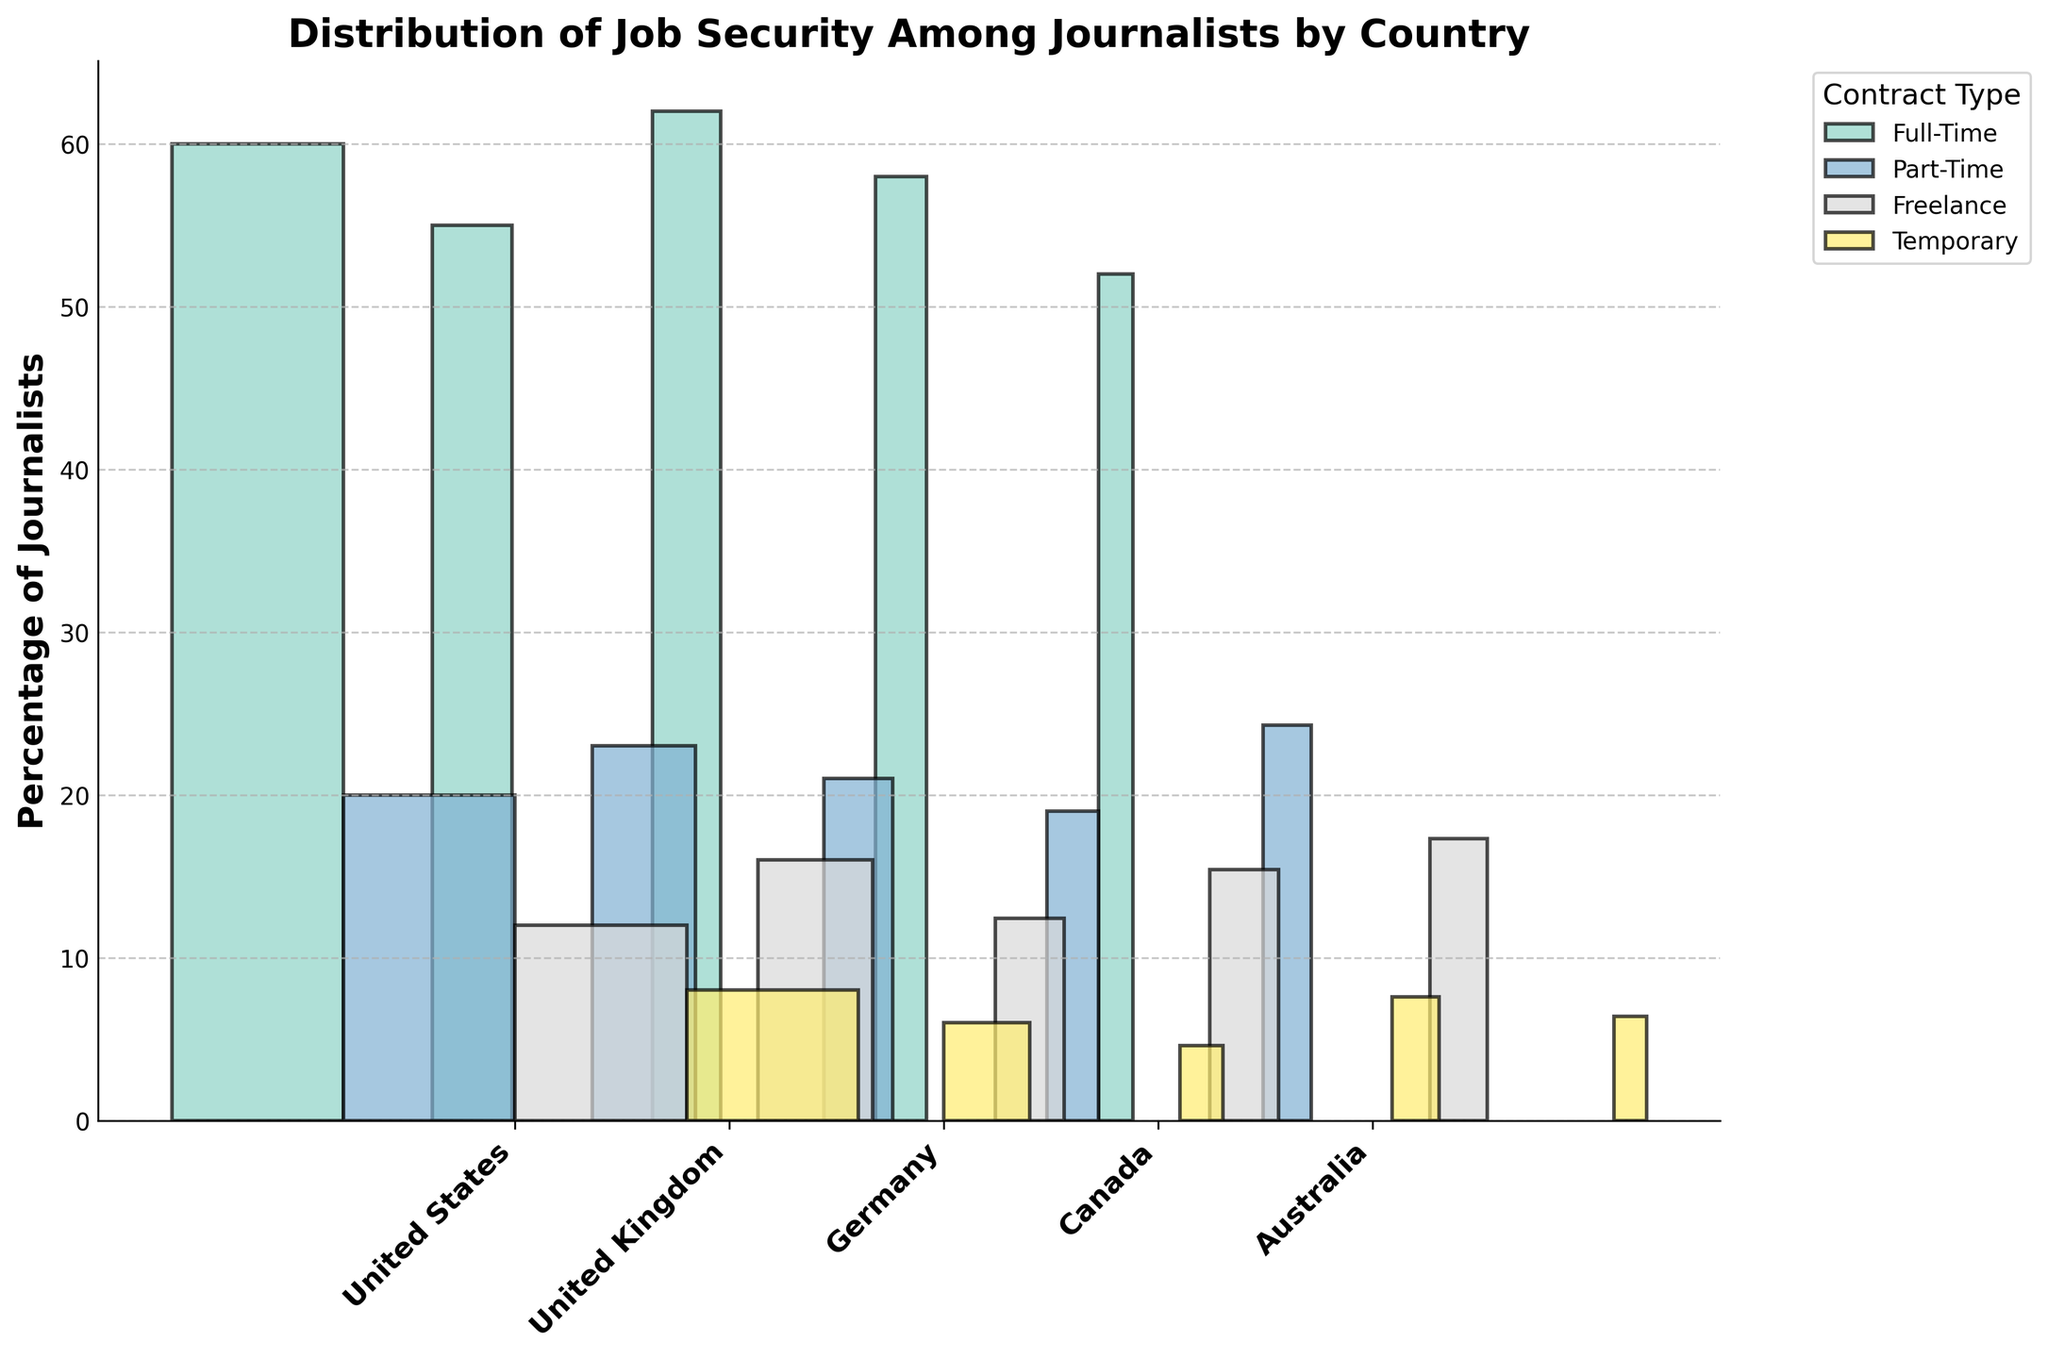What is the title of the plot? The title is usually found at the top of the plot. It indicates the main focus of the data presented. In this case, it reads "Distribution of Job Security Among Journalists by Country."
Answer: Distribution of Job Security Among Journalists by Country Which country has the highest percentage of journalists working full-time? To find this, look at the bars corresponding to the "Full-Time" label across all countries and identify the one with the highest value.
Answer: Germany Which contract type shows the most variation in percentages among the countries? By visually comparing the heights of the bars for each contract type across all countries, the "Full-Time" and "Part-Time" contract types exhibit notable differences in their heights. Therefore, the "Full-Time" contract type shows the most variation.
Answer: Full-Time How does the percentage of freelance journalists in Australia compare to that in the United Kingdom? Identify the height of the bars marked "Freelance" for both Australia and the United Kingdom. The comparison shows that the percentage in Australia is 17.3%, while in the United Kingdom, it is 16%.
Answer: Australia has a higher percentage What is the combined percentage of freelance and temporary journalists in the United States? Add the heights of the bars corresponding to "Freelance" and "Temporary" in the United States. The values are 12% and 8%, respectively. Thus, the combined total is 12 + 8 = 20%.
Answer: 20% Which country has the smallest number of journalists in total? By observing the widths of the bars, which represent the number of journalists, Australia's bars are the narrowest, indicating it has the smallest number of journalists.
Answer: Australia Is the proportion of part-time journalists in Canada higher or lower than in Germany? Compare the heights of the bars labeled "Part-Time" for Canada and Germany. Canada's part-time journalists percentage is 19%, while Germany's is 21%. Therefore, Canada's proportion is lower.
Answer: Lower What is the visual indication used to represent the number of journalists in each country? The plot uses the width of the bars to represent the number of journalists in each country, with wider bars indicating more journalists.
Answer: Width of bars What percentage of journalists in the United Kingdom are on temporary contracts? Locate the bar corresponding to "Temporary" in the United Kingdom and read off the percentage. The height of this bar indicates that 6% of UK journalists are on temporary contracts.
Answer: 6% 